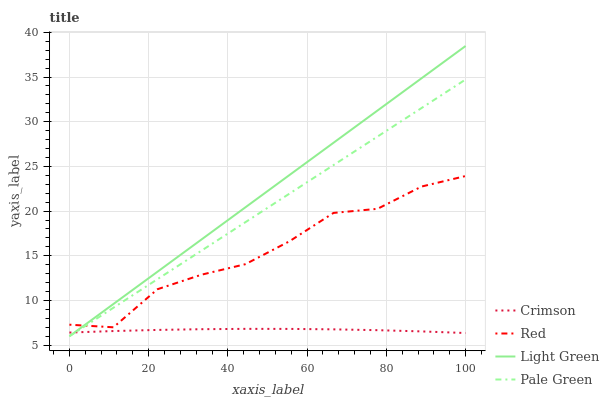Does Crimson have the minimum area under the curve?
Answer yes or no. Yes. Does Light Green have the maximum area under the curve?
Answer yes or no. Yes. Does Pale Green have the minimum area under the curve?
Answer yes or no. No. Does Pale Green have the maximum area under the curve?
Answer yes or no. No. Is Pale Green the smoothest?
Answer yes or no. Yes. Is Red the roughest?
Answer yes or no. Yes. Is Light Green the smoothest?
Answer yes or no. No. Is Light Green the roughest?
Answer yes or no. No. Does Pale Green have the lowest value?
Answer yes or no. Yes. Does Red have the lowest value?
Answer yes or no. No. Does Light Green have the highest value?
Answer yes or no. Yes. Does Pale Green have the highest value?
Answer yes or no. No. Is Crimson less than Red?
Answer yes or no. Yes. Is Red greater than Crimson?
Answer yes or no. Yes. Does Light Green intersect Crimson?
Answer yes or no. Yes. Is Light Green less than Crimson?
Answer yes or no. No. Is Light Green greater than Crimson?
Answer yes or no. No. Does Crimson intersect Red?
Answer yes or no. No. 